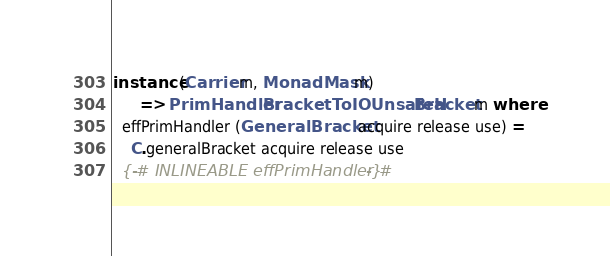<code> <loc_0><loc_0><loc_500><loc_500><_Haskell_>instance (Carrier m, MonadMask m)
      => PrimHandler BracketToIOUnsafeH Bracket m where
  effPrimHandler (GeneralBracket acquire release use) =
    C.generalBracket acquire release use
  {-# INLINEABLE effPrimHandler #-}
</code> 